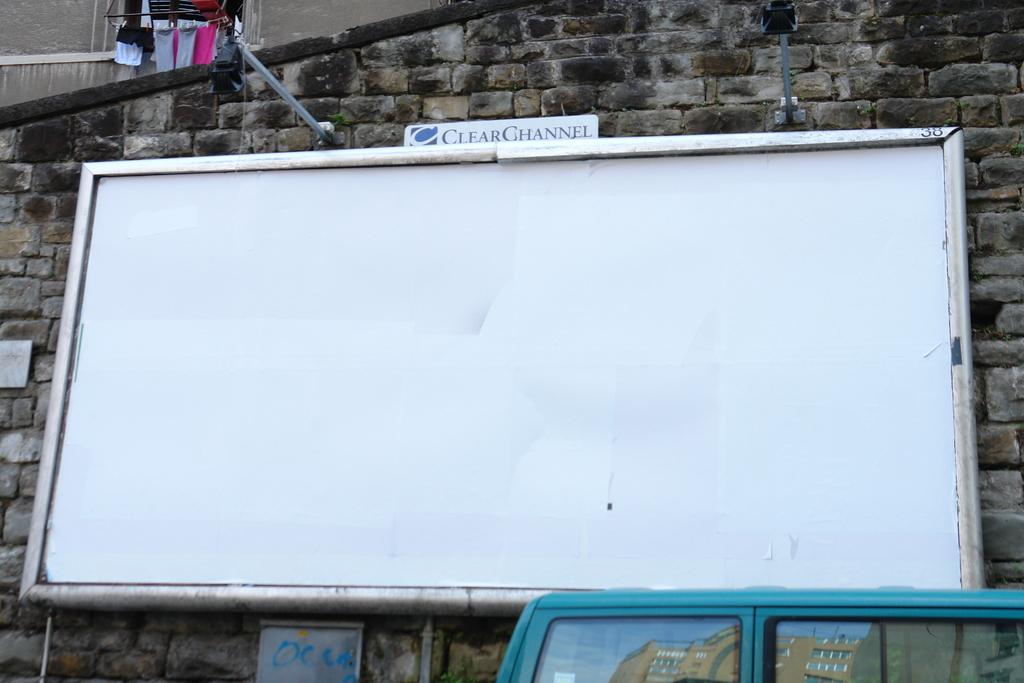<image>
Provide a brief description of the given image. A large white billboard that is blank posted on the side of a building and says ClearChannel above the board. 